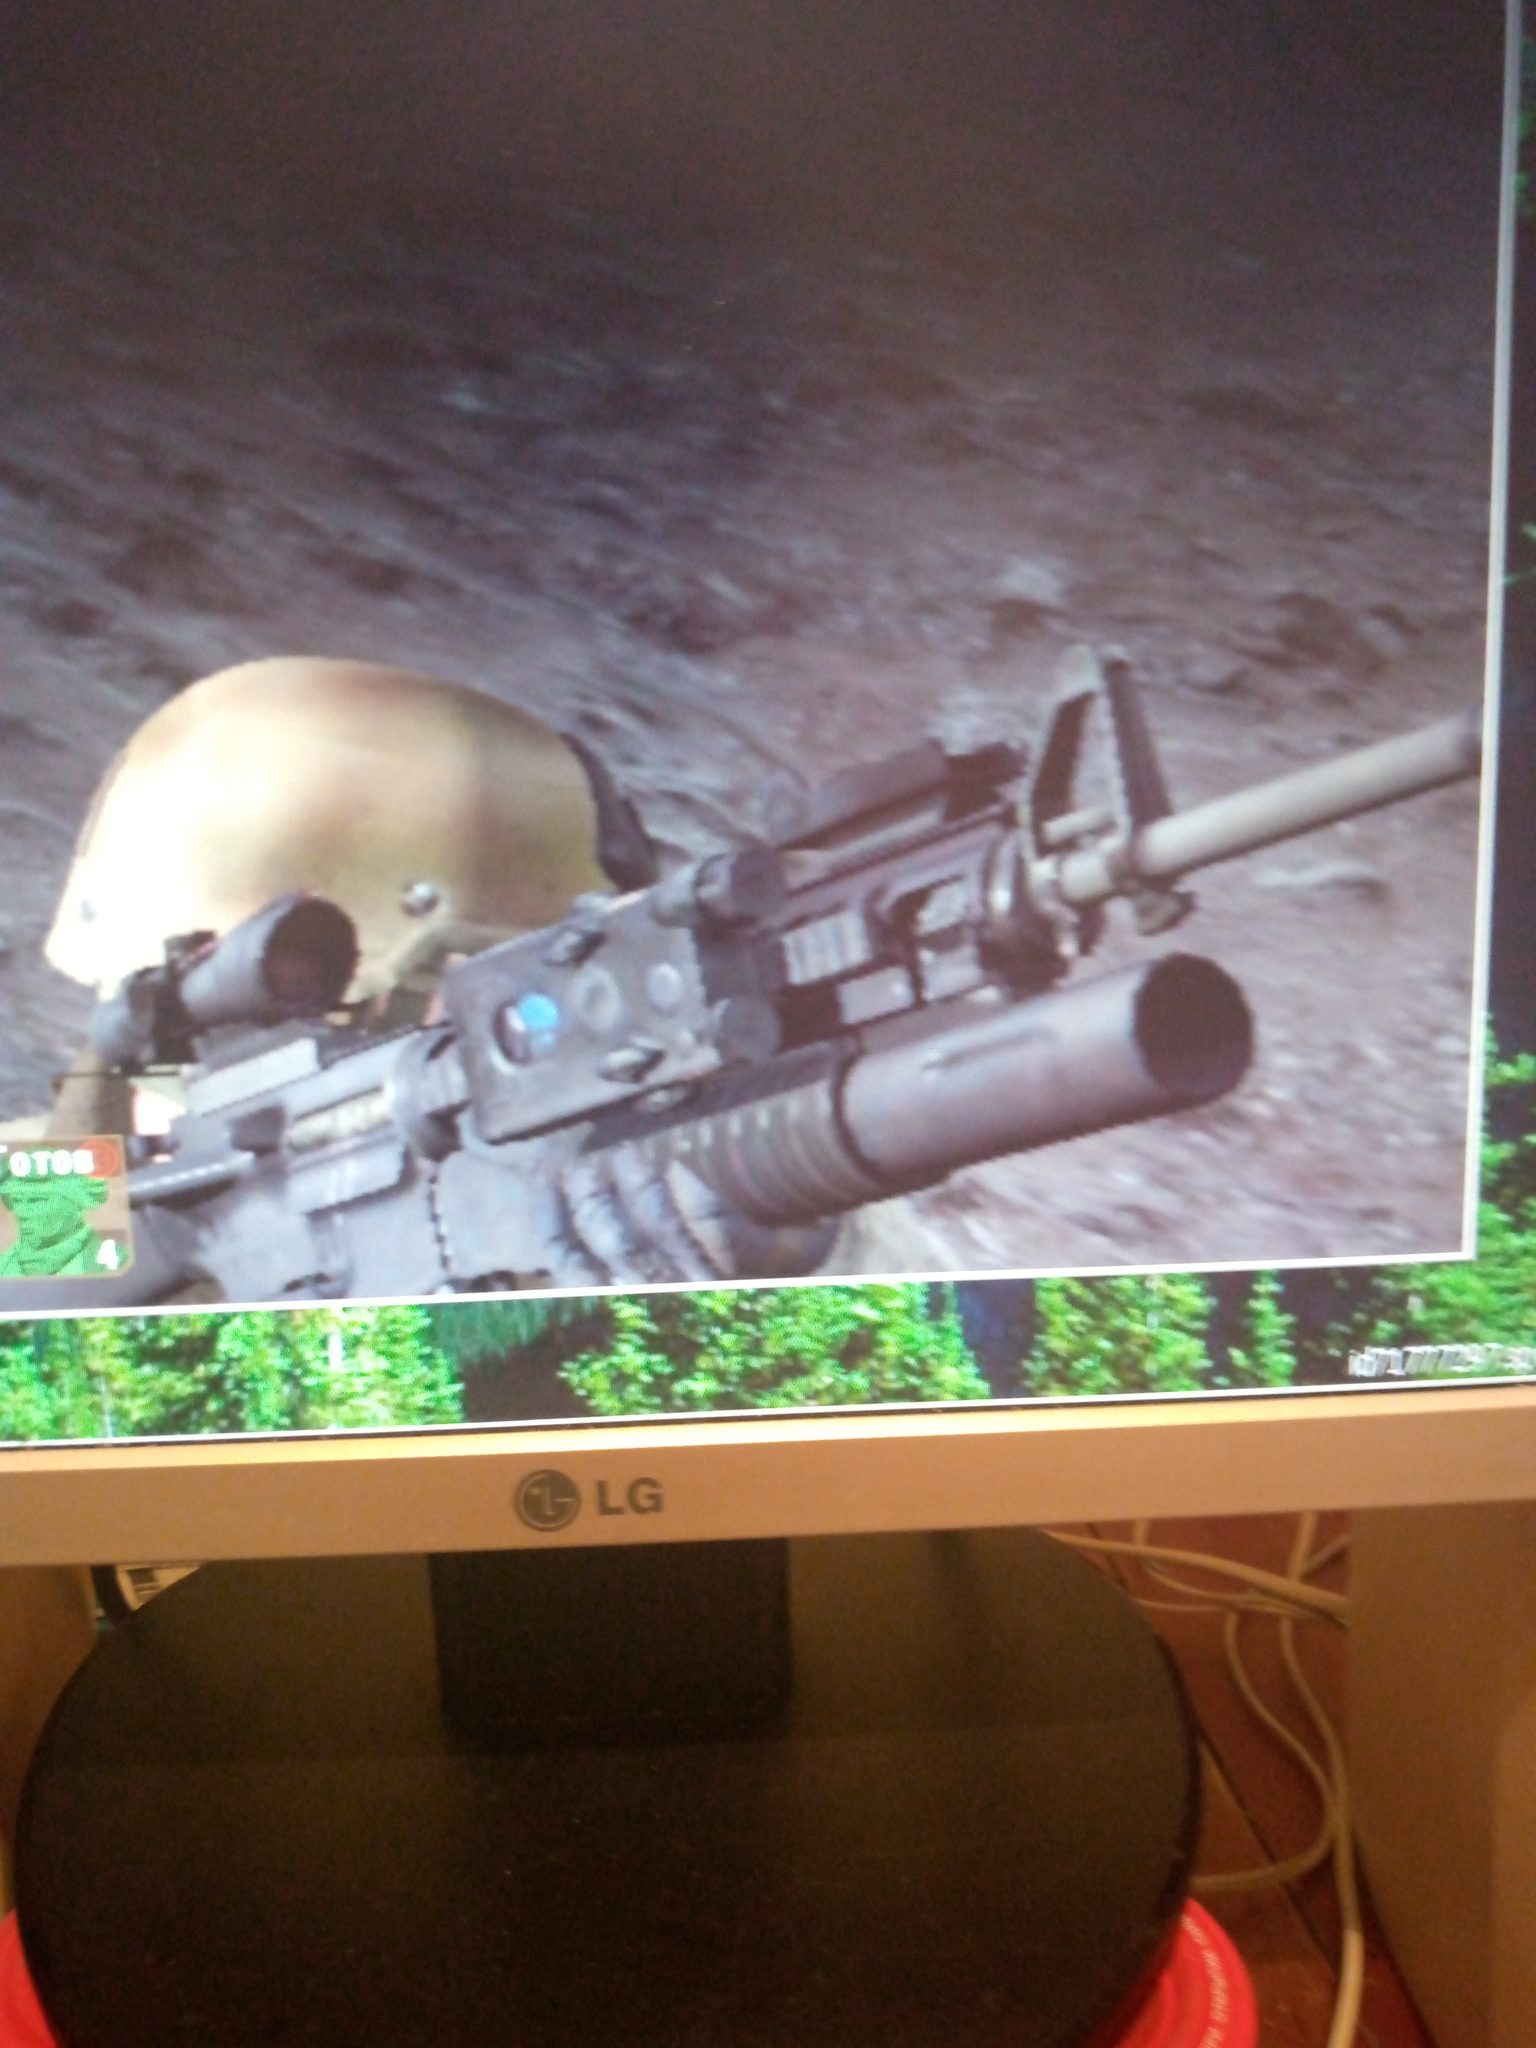What the game? Based on the image shown on the screen, this appears to be a first-person shooter video game. The screen displays a close-up view of a military-style assault rifle with attachments like a scope and what looks like a grenade launcher. There's also a tan-colored combat helmet visible in the corner of the image.

While I can't identify the specific game with certainty, these elements are common in modern military-themed shooter games. The high level of detail on the weapon model suggests it's likely a relatively recent game.

The image is being displayed on an LG monitor, which we can see from the logo at the bottom of the screen. Part of another image showing a forest or wooded area is visible at the bottom of the game screen, possibly part of the game's interface or menu.

Is there anything specific about the game or image you'd like me to elaborate on? 